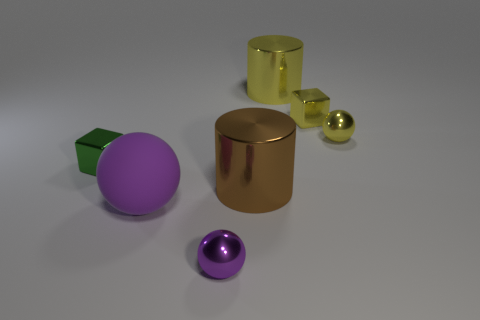What material is the large yellow object that is the same shape as the big brown object?
Keep it short and to the point. Metal. There is a green block that is made of the same material as the big brown object; what is its size?
Your answer should be very brief. Small. There is a shiny thing that is the same color as the rubber object; what shape is it?
Keep it short and to the point. Sphere. There is a shiny ball in front of the purple matte ball; is it the same color as the rubber ball?
Your answer should be very brief. Yes. There is a cube behind the yellow ball; is it the same size as the purple matte sphere?
Make the answer very short. No. What shape is the large rubber thing?
Provide a succinct answer. Sphere. What number of other tiny things are the same shape as the green object?
Your response must be concise. 1. How many things are on the left side of the small purple sphere and behind the large brown thing?
Your response must be concise. 1. What color is the large rubber ball?
Offer a very short reply. Purple. Are there any tiny gray cylinders made of the same material as the tiny green cube?
Provide a short and direct response. No. 